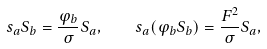Convert formula to latex. <formula><loc_0><loc_0><loc_500><loc_500>s _ { a } S _ { b } = \frac { \varphi _ { b } } { \sigma } S _ { a } , \quad s _ { a } ( \varphi _ { b } S _ { b } ) = \frac { F ^ { 2 } } { \sigma } S _ { a } ,</formula> 